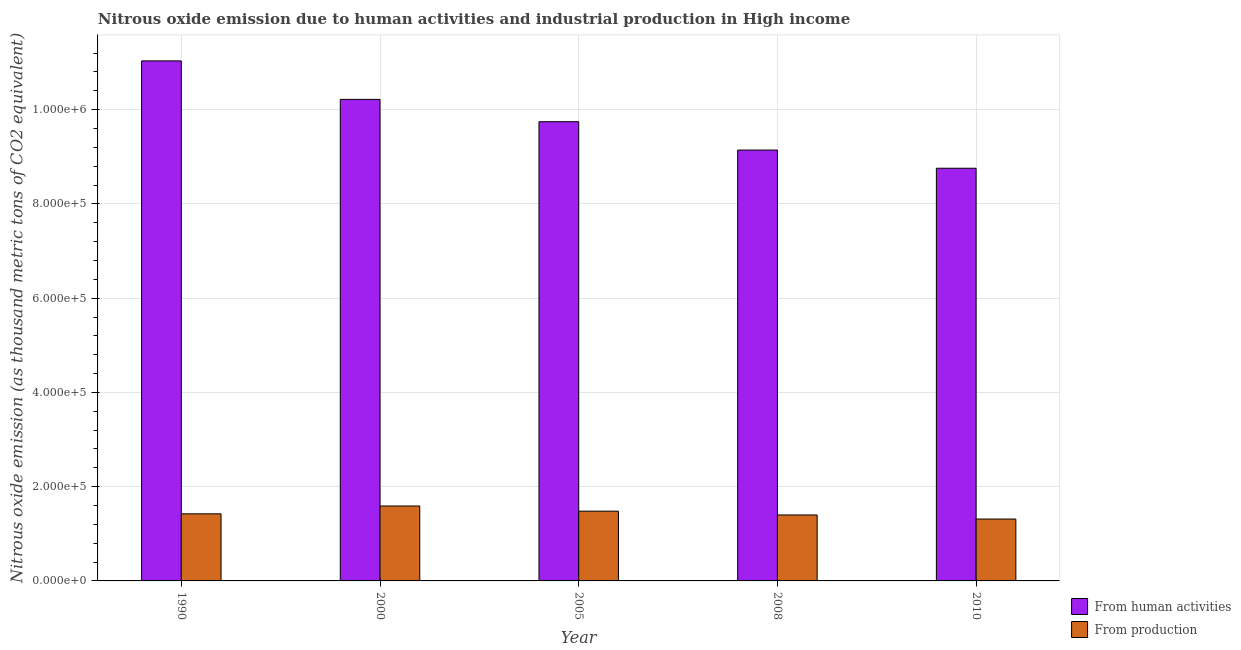How many different coloured bars are there?
Offer a terse response. 2. Are the number of bars per tick equal to the number of legend labels?
Your response must be concise. Yes. How many bars are there on the 2nd tick from the left?
Your response must be concise. 2. In how many cases, is the number of bars for a given year not equal to the number of legend labels?
Provide a short and direct response. 0. What is the amount of emissions generated from industries in 2005?
Give a very brief answer. 1.48e+05. Across all years, what is the maximum amount of emissions generated from industries?
Your answer should be very brief. 1.59e+05. Across all years, what is the minimum amount of emissions generated from industries?
Offer a terse response. 1.31e+05. In which year was the amount of emissions from human activities minimum?
Your response must be concise. 2010. What is the total amount of emissions generated from industries in the graph?
Keep it short and to the point. 7.21e+05. What is the difference between the amount of emissions generated from industries in 2000 and that in 2010?
Provide a short and direct response. 2.77e+04. What is the difference between the amount of emissions generated from industries in 2008 and the amount of emissions from human activities in 2010?
Provide a short and direct response. 8647.3. What is the average amount of emissions from human activities per year?
Offer a terse response. 9.78e+05. In the year 2008, what is the difference between the amount of emissions from human activities and amount of emissions generated from industries?
Your answer should be very brief. 0. In how many years, is the amount of emissions generated from industries greater than 760000 thousand metric tons?
Your answer should be very brief. 0. What is the ratio of the amount of emissions from human activities in 2008 to that in 2010?
Offer a terse response. 1.04. What is the difference between the highest and the second highest amount of emissions generated from industries?
Provide a succinct answer. 1.10e+04. What is the difference between the highest and the lowest amount of emissions from human activities?
Keep it short and to the point. 2.28e+05. Is the sum of the amount of emissions generated from industries in 2000 and 2010 greater than the maximum amount of emissions from human activities across all years?
Make the answer very short. Yes. What does the 2nd bar from the left in 2005 represents?
Offer a terse response. From production. What does the 2nd bar from the right in 2010 represents?
Provide a succinct answer. From human activities. Are all the bars in the graph horizontal?
Your response must be concise. No. Are the values on the major ticks of Y-axis written in scientific E-notation?
Ensure brevity in your answer.  Yes. Does the graph contain any zero values?
Provide a succinct answer. No. Where does the legend appear in the graph?
Provide a succinct answer. Bottom right. What is the title of the graph?
Your answer should be very brief. Nitrous oxide emission due to human activities and industrial production in High income. Does "Mineral" appear as one of the legend labels in the graph?
Your answer should be very brief. No. What is the label or title of the Y-axis?
Your answer should be compact. Nitrous oxide emission (as thousand metric tons of CO2 equivalent). What is the Nitrous oxide emission (as thousand metric tons of CO2 equivalent) of From human activities in 1990?
Offer a very short reply. 1.10e+06. What is the Nitrous oxide emission (as thousand metric tons of CO2 equivalent) in From production in 1990?
Your response must be concise. 1.42e+05. What is the Nitrous oxide emission (as thousand metric tons of CO2 equivalent) of From human activities in 2000?
Your answer should be very brief. 1.02e+06. What is the Nitrous oxide emission (as thousand metric tons of CO2 equivalent) in From production in 2000?
Give a very brief answer. 1.59e+05. What is the Nitrous oxide emission (as thousand metric tons of CO2 equivalent) of From human activities in 2005?
Keep it short and to the point. 9.74e+05. What is the Nitrous oxide emission (as thousand metric tons of CO2 equivalent) in From production in 2005?
Your response must be concise. 1.48e+05. What is the Nitrous oxide emission (as thousand metric tons of CO2 equivalent) of From human activities in 2008?
Offer a very short reply. 9.14e+05. What is the Nitrous oxide emission (as thousand metric tons of CO2 equivalent) in From production in 2008?
Keep it short and to the point. 1.40e+05. What is the Nitrous oxide emission (as thousand metric tons of CO2 equivalent) of From human activities in 2010?
Provide a short and direct response. 8.76e+05. What is the Nitrous oxide emission (as thousand metric tons of CO2 equivalent) of From production in 2010?
Your answer should be very brief. 1.31e+05. Across all years, what is the maximum Nitrous oxide emission (as thousand metric tons of CO2 equivalent) in From human activities?
Make the answer very short. 1.10e+06. Across all years, what is the maximum Nitrous oxide emission (as thousand metric tons of CO2 equivalent) of From production?
Offer a terse response. 1.59e+05. Across all years, what is the minimum Nitrous oxide emission (as thousand metric tons of CO2 equivalent) of From human activities?
Provide a short and direct response. 8.76e+05. Across all years, what is the minimum Nitrous oxide emission (as thousand metric tons of CO2 equivalent) in From production?
Your response must be concise. 1.31e+05. What is the total Nitrous oxide emission (as thousand metric tons of CO2 equivalent) in From human activities in the graph?
Make the answer very short. 4.89e+06. What is the total Nitrous oxide emission (as thousand metric tons of CO2 equivalent) of From production in the graph?
Ensure brevity in your answer.  7.21e+05. What is the difference between the Nitrous oxide emission (as thousand metric tons of CO2 equivalent) in From human activities in 1990 and that in 2000?
Ensure brevity in your answer.  8.17e+04. What is the difference between the Nitrous oxide emission (as thousand metric tons of CO2 equivalent) of From production in 1990 and that in 2000?
Offer a terse response. -1.66e+04. What is the difference between the Nitrous oxide emission (as thousand metric tons of CO2 equivalent) of From human activities in 1990 and that in 2005?
Ensure brevity in your answer.  1.29e+05. What is the difference between the Nitrous oxide emission (as thousand metric tons of CO2 equivalent) in From production in 1990 and that in 2005?
Give a very brief answer. -5648.4. What is the difference between the Nitrous oxide emission (as thousand metric tons of CO2 equivalent) in From human activities in 1990 and that in 2008?
Your answer should be compact. 1.89e+05. What is the difference between the Nitrous oxide emission (as thousand metric tons of CO2 equivalent) in From production in 1990 and that in 2008?
Your answer should be very brief. 2410.2. What is the difference between the Nitrous oxide emission (as thousand metric tons of CO2 equivalent) of From human activities in 1990 and that in 2010?
Keep it short and to the point. 2.28e+05. What is the difference between the Nitrous oxide emission (as thousand metric tons of CO2 equivalent) of From production in 1990 and that in 2010?
Your answer should be very brief. 1.11e+04. What is the difference between the Nitrous oxide emission (as thousand metric tons of CO2 equivalent) in From human activities in 2000 and that in 2005?
Offer a very short reply. 4.74e+04. What is the difference between the Nitrous oxide emission (as thousand metric tons of CO2 equivalent) of From production in 2000 and that in 2005?
Your response must be concise. 1.10e+04. What is the difference between the Nitrous oxide emission (as thousand metric tons of CO2 equivalent) of From human activities in 2000 and that in 2008?
Provide a succinct answer. 1.08e+05. What is the difference between the Nitrous oxide emission (as thousand metric tons of CO2 equivalent) in From production in 2000 and that in 2008?
Your answer should be very brief. 1.90e+04. What is the difference between the Nitrous oxide emission (as thousand metric tons of CO2 equivalent) in From human activities in 2000 and that in 2010?
Provide a short and direct response. 1.46e+05. What is the difference between the Nitrous oxide emission (as thousand metric tons of CO2 equivalent) of From production in 2000 and that in 2010?
Your answer should be compact. 2.77e+04. What is the difference between the Nitrous oxide emission (as thousand metric tons of CO2 equivalent) in From human activities in 2005 and that in 2008?
Provide a succinct answer. 6.02e+04. What is the difference between the Nitrous oxide emission (as thousand metric tons of CO2 equivalent) of From production in 2005 and that in 2008?
Make the answer very short. 8058.6. What is the difference between the Nitrous oxide emission (as thousand metric tons of CO2 equivalent) of From human activities in 2005 and that in 2010?
Your response must be concise. 9.88e+04. What is the difference between the Nitrous oxide emission (as thousand metric tons of CO2 equivalent) in From production in 2005 and that in 2010?
Your response must be concise. 1.67e+04. What is the difference between the Nitrous oxide emission (as thousand metric tons of CO2 equivalent) in From human activities in 2008 and that in 2010?
Keep it short and to the point. 3.86e+04. What is the difference between the Nitrous oxide emission (as thousand metric tons of CO2 equivalent) in From production in 2008 and that in 2010?
Keep it short and to the point. 8647.3. What is the difference between the Nitrous oxide emission (as thousand metric tons of CO2 equivalent) of From human activities in 1990 and the Nitrous oxide emission (as thousand metric tons of CO2 equivalent) of From production in 2000?
Your answer should be very brief. 9.45e+05. What is the difference between the Nitrous oxide emission (as thousand metric tons of CO2 equivalent) of From human activities in 1990 and the Nitrous oxide emission (as thousand metric tons of CO2 equivalent) of From production in 2005?
Give a very brief answer. 9.55e+05. What is the difference between the Nitrous oxide emission (as thousand metric tons of CO2 equivalent) of From human activities in 1990 and the Nitrous oxide emission (as thousand metric tons of CO2 equivalent) of From production in 2008?
Provide a succinct answer. 9.64e+05. What is the difference between the Nitrous oxide emission (as thousand metric tons of CO2 equivalent) of From human activities in 1990 and the Nitrous oxide emission (as thousand metric tons of CO2 equivalent) of From production in 2010?
Make the answer very short. 9.72e+05. What is the difference between the Nitrous oxide emission (as thousand metric tons of CO2 equivalent) of From human activities in 2000 and the Nitrous oxide emission (as thousand metric tons of CO2 equivalent) of From production in 2005?
Provide a short and direct response. 8.74e+05. What is the difference between the Nitrous oxide emission (as thousand metric tons of CO2 equivalent) in From human activities in 2000 and the Nitrous oxide emission (as thousand metric tons of CO2 equivalent) in From production in 2008?
Make the answer very short. 8.82e+05. What is the difference between the Nitrous oxide emission (as thousand metric tons of CO2 equivalent) of From human activities in 2000 and the Nitrous oxide emission (as thousand metric tons of CO2 equivalent) of From production in 2010?
Provide a short and direct response. 8.90e+05. What is the difference between the Nitrous oxide emission (as thousand metric tons of CO2 equivalent) in From human activities in 2005 and the Nitrous oxide emission (as thousand metric tons of CO2 equivalent) in From production in 2008?
Keep it short and to the point. 8.34e+05. What is the difference between the Nitrous oxide emission (as thousand metric tons of CO2 equivalent) in From human activities in 2005 and the Nitrous oxide emission (as thousand metric tons of CO2 equivalent) in From production in 2010?
Offer a terse response. 8.43e+05. What is the difference between the Nitrous oxide emission (as thousand metric tons of CO2 equivalent) in From human activities in 2008 and the Nitrous oxide emission (as thousand metric tons of CO2 equivalent) in From production in 2010?
Your answer should be compact. 7.83e+05. What is the average Nitrous oxide emission (as thousand metric tons of CO2 equivalent) in From human activities per year?
Your answer should be compact. 9.78e+05. What is the average Nitrous oxide emission (as thousand metric tons of CO2 equivalent) in From production per year?
Your response must be concise. 1.44e+05. In the year 1990, what is the difference between the Nitrous oxide emission (as thousand metric tons of CO2 equivalent) in From human activities and Nitrous oxide emission (as thousand metric tons of CO2 equivalent) in From production?
Make the answer very short. 9.61e+05. In the year 2000, what is the difference between the Nitrous oxide emission (as thousand metric tons of CO2 equivalent) of From human activities and Nitrous oxide emission (as thousand metric tons of CO2 equivalent) of From production?
Your answer should be very brief. 8.63e+05. In the year 2005, what is the difference between the Nitrous oxide emission (as thousand metric tons of CO2 equivalent) of From human activities and Nitrous oxide emission (as thousand metric tons of CO2 equivalent) of From production?
Ensure brevity in your answer.  8.26e+05. In the year 2008, what is the difference between the Nitrous oxide emission (as thousand metric tons of CO2 equivalent) in From human activities and Nitrous oxide emission (as thousand metric tons of CO2 equivalent) in From production?
Offer a terse response. 7.74e+05. In the year 2010, what is the difference between the Nitrous oxide emission (as thousand metric tons of CO2 equivalent) in From human activities and Nitrous oxide emission (as thousand metric tons of CO2 equivalent) in From production?
Your answer should be compact. 7.44e+05. What is the ratio of the Nitrous oxide emission (as thousand metric tons of CO2 equivalent) of From production in 1990 to that in 2000?
Provide a short and direct response. 0.9. What is the ratio of the Nitrous oxide emission (as thousand metric tons of CO2 equivalent) in From human activities in 1990 to that in 2005?
Offer a terse response. 1.13. What is the ratio of the Nitrous oxide emission (as thousand metric tons of CO2 equivalent) of From production in 1990 to that in 2005?
Your response must be concise. 0.96. What is the ratio of the Nitrous oxide emission (as thousand metric tons of CO2 equivalent) in From human activities in 1990 to that in 2008?
Offer a very short reply. 1.21. What is the ratio of the Nitrous oxide emission (as thousand metric tons of CO2 equivalent) in From production in 1990 to that in 2008?
Give a very brief answer. 1.02. What is the ratio of the Nitrous oxide emission (as thousand metric tons of CO2 equivalent) in From human activities in 1990 to that in 2010?
Your response must be concise. 1.26. What is the ratio of the Nitrous oxide emission (as thousand metric tons of CO2 equivalent) of From production in 1990 to that in 2010?
Ensure brevity in your answer.  1.08. What is the ratio of the Nitrous oxide emission (as thousand metric tons of CO2 equivalent) of From human activities in 2000 to that in 2005?
Provide a short and direct response. 1.05. What is the ratio of the Nitrous oxide emission (as thousand metric tons of CO2 equivalent) in From production in 2000 to that in 2005?
Give a very brief answer. 1.07. What is the ratio of the Nitrous oxide emission (as thousand metric tons of CO2 equivalent) in From human activities in 2000 to that in 2008?
Give a very brief answer. 1.12. What is the ratio of the Nitrous oxide emission (as thousand metric tons of CO2 equivalent) of From production in 2000 to that in 2008?
Your response must be concise. 1.14. What is the ratio of the Nitrous oxide emission (as thousand metric tons of CO2 equivalent) of From human activities in 2000 to that in 2010?
Ensure brevity in your answer.  1.17. What is the ratio of the Nitrous oxide emission (as thousand metric tons of CO2 equivalent) of From production in 2000 to that in 2010?
Your answer should be compact. 1.21. What is the ratio of the Nitrous oxide emission (as thousand metric tons of CO2 equivalent) in From human activities in 2005 to that in 2008?
Offer a very short reply. 1.07. What is the ratio of the Nitrous oxide emission (as thousand metric tons of CO2 equivalent) of From production in 2005 to that in 2008?
Keep it short and to the point. 1.06. What is the ratio of the Nitrous oxide emission (as thousand metric tons of CO2 equivalent) of From human activities in 2005 to that in 2010?
Your response must be concise. 1.11. What is the ratio of the Nitrous oxide emission (as thousand metric tons of CO2 equivalent) in From production in 2005 to that in 2010?
Offer a terse response. 1.13. What is the ratio of the Nitrous oxide emission (as thousand metric tons of CO2 equivalent) of From human activities in 2008 to that in 2010?
Provide a succinct answer. 1.04. What is the ratio of the Nitrous oxide emission (as thousand metric tons of CO2 equivalent) of From production in 2008 to that in 2010?
Offer a terse response. 1.07. What is the difference between the highest and the second highest Nitrous oxide emission (as thousand metric tons of CO2 equivalent) in From human activities?
Your answer should be very brief. 8.17e+04. What is the difference between the highest and the second highest Nitrous oxide emission (as thousand metric tons of CO2 equivalent) of From production?
Provide a short and direct response. 1.10e+04. What is the difference between the highest and the lowest Nitrous oxide emission (as thousand metric tons of CO2 equivalent) in From human activities?
Offer a terse response. 2.28e+05. What is the difference between the highest and the lowest Nitrous oxide emission (as thousand metric tons of CO2 equivalent) of From production?
Your response must be concise. 2.77e+04. 